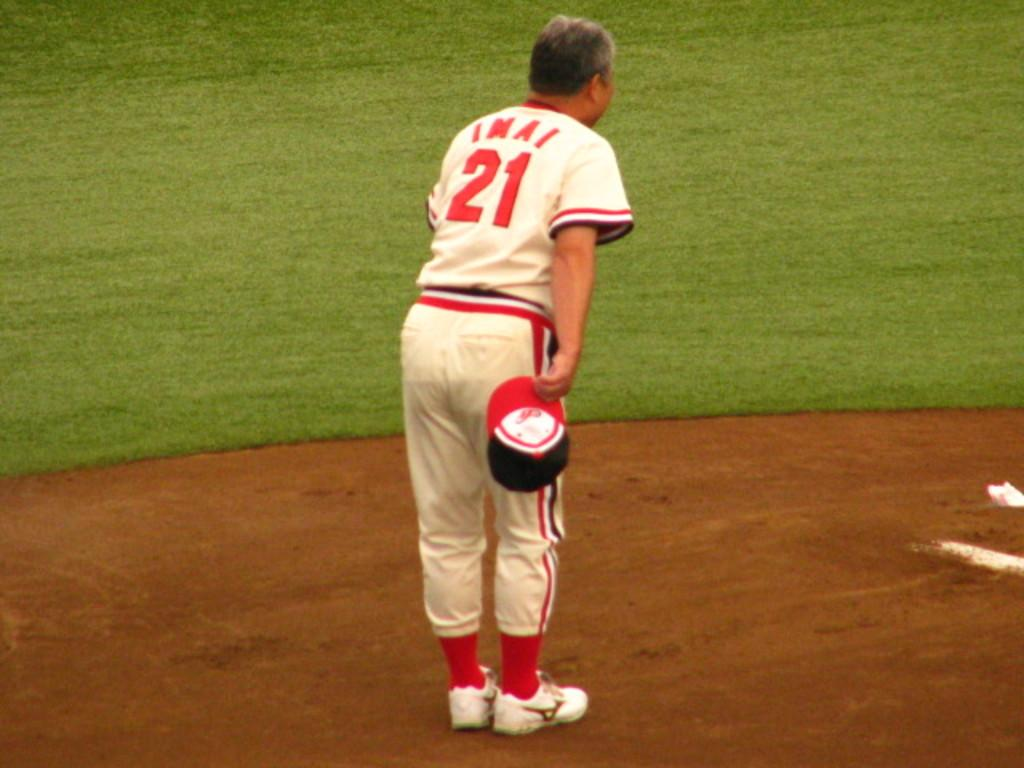Provide a one-sentence caption for the provided image. A baseball player with a jersey that says IMAI and the number 21. 